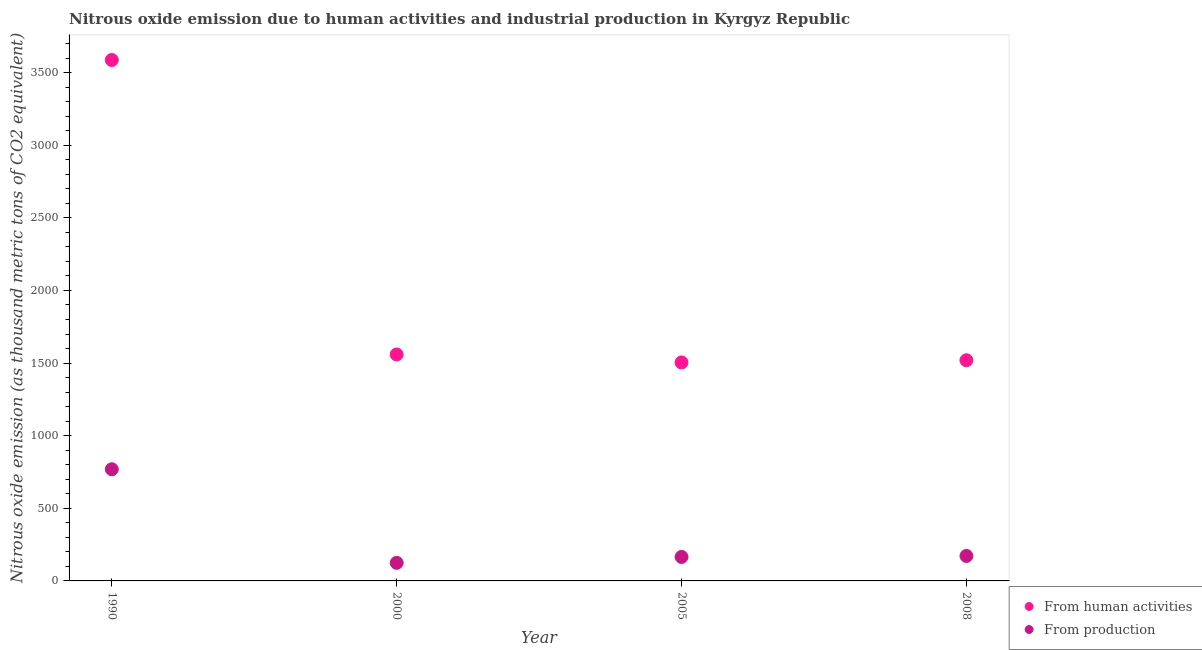Is the number of dotlines equal to the number of legend labels?
Your answer should be compact. Yes. What is the amount of emissions generated from industries in 1990?
Make the answer very short. 768.8. Across all years, what is the maximum amount of emissions generated from industries?
Give a very brief answer. 768.8. Across all years, what is the minimum amount of emissions generated from industries?
Provide a succinct answer. 124.4. In which year was the amount of emissions generated from industries maximum?
Provide a short and direct response. 1990. What is the total amount of emissions generated from industries in the graph?
Make the answer very short. 1230.3. What is the difference between the amount of emissions from human activities in 1990 and that in 2005?
Your response must be concise. 2082.2. What is the difference between the amount of emissions generated from industries in 2000 and the amount of emissions from human activities in 2005?
Your answer should be very brief. -1379.9. What is the average amount of emissions from human activities per year?
Keep it short and to the point. 2042.3. In the year 1990, what is the difference between the amount of emissions from human activities and amount of emissions generated from industries?
Offer a very short reply. 2817.7. What is the ratio of the amount of emissions generated from industries in 2000 to that in 2008?
Your answer should be compact. 0.72. Is the amount of emissions from human activities in 1990 less than that in 2005?
Your response must be concise. No. What is the difference between the highest and the second highest amount of emissions from human activities?
Offer a terse response. 2027.4. What is the difference between the highest and the lowest amount of emissions from human activities?
Your answer should be very brief. 2082.2. Does the amount of emissions from human activities monotonically increase over the years?
Your response must be concise. No. Is the amount of emissions generated from industries strictly less than the amount of emissions from human activities over the years?
Provide a short and direct response. Yes. How many years are there in the graph?
Give a very brief answer. 4. What is the difference between two consecutive major ticks on the Y-axis?
Provide a succinct answer. 500. Are the values on the major ticks of Y-axis written in scientific E-notation?
Your answer should be compact. No. Does the graph contain any zero values?
Offer a very short reply. No. Where does the legend appear in the graph?
Ensure brevity in your answer.  Bottom right. How are the legend labels stacked?
Make the answer very short. Vertical. What is the title of the graph?
Make the answer very short. Nitrous oxide emission due to human activities and industrial production in Kyrgyz Republic. Does "Resident" appear as one of the legend labels in the graph?
Your response must be concise. No. What is the label or title of the Y-axis?
Provide a succinct answer. Nitrous oxide emission (as thousand metric tons of CO2 equivalent). What is the Nitrous oxide emission (as thousand metric tons of CO2 equivalent) of From human activities in 1990?
Your answer should be very brief. 3586.5. What is the Nitrous oxide emission (as thousand metric tons of CO2 equivalent) in From production in 1990?
Provide a short and direct response. 768.8. What is the Nitrous oxide emission (as thousand metric tons of CO2 equivalent) of From human activities in 2000?
Provide a succinct answer. 1559.1. What is the Nitrous oxide emission (as thousand metric tons of CO2 equivalent) in From production in 2000?
Your response must be concise. 124.4. What is the Nitrous oxide emission (as thousand metric tons of CO2 equivalent) in From human activities in 2005?
Keep it short and to the point. 1504.3. What is the Nitrous oxide emission (as thousand metric tons of CO2 equivalent) of From production in 2005?
Ensure brevity in your answer.  165.2. What is the Nitrous oxide emission (as thousand metric tons of CO2 equivalent) of From human activities in 2008?
Make the answer very short. 1519.3. What is the Nitrous oxide emission (as thousand metric tons of CO2 equivalent) of From production in 2008?
Provide a succinct answer. 171.9. Across all years, what is the maximum Nitrous oxide emission (as thousand metric tons of CO2 equivalent) of From human activities?
Your answer should be compact. 3586.5. Across all years, what is the maximum Nitrous oxide emission (as thousand metric tons of CO2 equivalent) in From production?
Offer a terse response. 768.8. Across all years, what is the minimum Nitrous oxide emission (as thousand metric tons of CO2 equivalent) in From human activities?
Your response must be concise. 1504.3. Across all years, what is the minimum Nitrous oxide emission (as thousand metric tons of CO2 equivalent) of From production?
Keep it short and to the point. 124.4. What is the total Nitrous oxide emission (as thousand metric tons of CO2 equivalent) of From human activities in the graph?
Ensure brevity in your answer.  8169.2. What is the total Nitrous oxide emission (as thousand metric tons of CO2 equivalent) in From production in the graph?
Ensure brevity in your answer.  1230.3. What is the difference between the Nitrous oxide emission (as thousand metric tons of CO2 equivalent) in From human activities in 1990 and that in 2000?
Your answer should be very brief. 2027.4. What is the difference between the Nitrous oxide emission (as thousand metric tons of CO2 equivalent) of From production in 1990 and that in 2000?
Your response must be concise. 644.4. What is the difference between the Nitrous oxide emission (as thousand metric tons of CO2 equivalent) in From human activities in 1990 and that in 2005?
Keep it short and to the point. 2082.2. What is the difference between the Nitrous oxide emission (as thousand metric tons of CO2 equivalent) of From production in 1990 and that in 2005?
Offer a terse response. 603.6. What is the difference between the Nitrous oxide emission (as thousand metric tons of CO2 equivalent) in From human activities in 1990 and that in 2008?
Ensure brevity in your answer.  2067.2. What is the difference between the Nitrous oxide emission (as thousand metric tons of CO2 equivalent) of From production in 1990 and that in 2008?
Make the answer very short. 596.9. What is the difference between the Nitrous oxide emission (as thousand metric tons of CO2 equivalent) in From human activities in 2000 and that in 2005?
Your answer should be very brief. 54.8. What is the difference between the Nitrous oxide emission (as thousand metric tons of CO2 equivalent) of From production in 2000 and that in 2005?
Your answer should be compact. -40.8. What is the difference between the Nitrous oxide emission (as thousand metric tons of CO2 equivalent) of From human activities in 2000 and that in 2008?
Provide a succinct answer. 39.8. What is the difference between the Nitrous oxide emission (as thousand metric tons of CO2 equivalent) of From production in 2000 and that in 2008?
Offer a terse response. -47.5. What is the difference between the Nitrous oxide emission (as thousand metric tons of CO2 equivalent) of From human activities in 2005 and that in 2008?
Keep it short and to the point. -15. What is the difference between the Nitrous oxide emission (as thousand metric tons of CO2 equivalent) of From human activities in 1990 and the Nitrous oxide emission (as thousand metric tons of CO2 equivalent) of From production in 2000?
Your answer should be compact. 3462.1. What is the difference between the Nitrous oxide emission (as thousand metric tons of CO2 equivalent) in From human activities in 1990 and the Nitrous oxide emission (as thousand metric tons of CO2 equivalent) in From production in 2005?
Provide a short and direct response. 3421.3. What is the difference between the Nitrous oxide emission (as thousand metric tons of CO2 equivalent) in From human activities in 1990 and the Nitrous oxide emission (as thousand metric tons of CO2 equivalent) in From production in 2008?
Offer a terse response. 3414.6. What is the difference between the Nitrous oxide emission (as thousand metric tons of CO2 equivalent) in From human activities in 2000 and the Nitrous oxide emission (as thousand metric tons of CO2 equivalent) in From production in 2005?
Provide a succinct answer. 1393.9. What is the difference between the Nitrous oxide emission (as thousand metric tons of CO2 equivalent) of From human activities in 2000 and the Nitrous oxide emission (as thousand metric tons of CO2 equivalent) of From production in 2008?
Make the answer very short. 1387.2. What is the difference between the Nitrous oxide emission (as thousand metric tons of CO2 equivalent) of From human activities in 2005 and the Nitrous oxide emission (as thousand metric tons of CO2 equivalent) of From production in 2008?
Your answer should be very brief. 1332.4. What is the average Nitrous oxide emission (as thousand metric tons of CO2 equivalent) in From human activities per year?
Keep it short and to the point. 2042.3. What is the average Nitrous oxide emission (as thousand metric tons of CO2 equivalent) of From production per year?
Your answer should be very brief. 307.57. In the year 1990, what is the difference between the Nitrous oxide emission (as thousand metric tons of CO2 equivalent) in From human activities and Nitrous oxide emission (as thousand metric tons of CO2 equivalent) in From production?
Provide a short and direct response. 2817.7. In the year 2000, what is the difference between the Nitrous oxide emission (as thousand metric tons of CO2 equivalent) in From human activities and Nitrous oxide emission (as thousand metric tons of CO2 equivalent) in From production?
Ensure brevity in your answer.  1434.7. In the year 2005, what is the difference between the Nitrous oxide emission (as thousand metric tons of CO2 equivalent) of From human activities and Nitrous oxide emission (as thousand metric tons of CO2 equivalent) of From production?
Offer a terse response. 1339.1. In the year 2008, what is the difference between the Nitrous oxide emission (as thousand metric tons of CO2 equivalent) in From human activities and Nitrous oxide emission (as thousand metric tons of CO2 equivalent) in From production?
Ensure brevity in your answer.  1347.4. What is the ratio of the Nitrous oxide emission (as thousand metric tons of CO2 equivalent) of From human activities in 1990 to that in 2000?
Your answer should be very brief. 2.3. What is the ratio of the Nitrous oxide emission (as thousand metric tons of CO2 equivalent) of From production in 1990 to that in 2000?
Provide a short and direct response. 6.18. What is the ratio of the Nitrous oxide emission (as thousand metric tons of CO2 equivalent) in From human activities in 1990 to that in 2005?
Your response must be concise. 2.38. What is the ratio of the Nitrous oxide emission (as thousand metric tons of CO2 equivalent) of From production in 1990 to that in 2005?
Your response must be concise. 4.65. What is the ratio of the Nitrous oxide emission (as thousand metric tons of CO2 equivalent) in From human activities in 1990 to that in 2008?
Your response must be concise. 2.36. What is the ratio of the Nitrous oxide emission (as thousand metric tons of CO2 equivalent) in From production in 1990 to that in 2008?
Your response must be concise. 4.47. What is the ratio of the Nitrous oxide emission (as thousand metric tons of CO2 equivalent) in From human activities in 2000 to that in 2005?
Make the answer very short. 1.04. What is the ratio of the Nitrous oxide emission (as thousand metric tons of CO2 equivalent) in From production in 2000 to that in 2005?
Offer a very short reply. 0.75. What is the ratio of the Nitrous oxide emission (as thousand metric tons of CO2 equivalent) in From human activities in 2000 to that in 2008?
Offer a very short reply. 1.03. What is the ratio of the Nitrous oxide emission (as thousand metric tons of CO2 equivalent) in From production in 2000 to that in 2008?
Offer a terse response. 0.72. What is the ratio of the Nitrous oxide emission (as thousand metric tons of CO2 equivalent) of From production in 2005 to that in 2008?
Give a very brief answer. 0.96. What is the difference between the highest and the second highest Nitrous oxide emission (as thousand metric tons of CO2 equivalent) of From human activities?
Your answer should be very brief. 2027.4. What is the difference between the highest and the second highest Nitrous oxide emission (as thousand metric tons of CO2 equivalent) of From production?
Offer a terse response. 596.9. What is the difference between the highest and the lowest Nitrous oxide emission (as thousand metric tons of CO2 equivalent) in From human activities?
Your response must be concise. 2082.2. What is the difference between the highest and the lowest Nitrous oxide emission (as thousand metric tons of CO2 equivalent) of From production?
Ensure brevity in your answer.  644.4. 